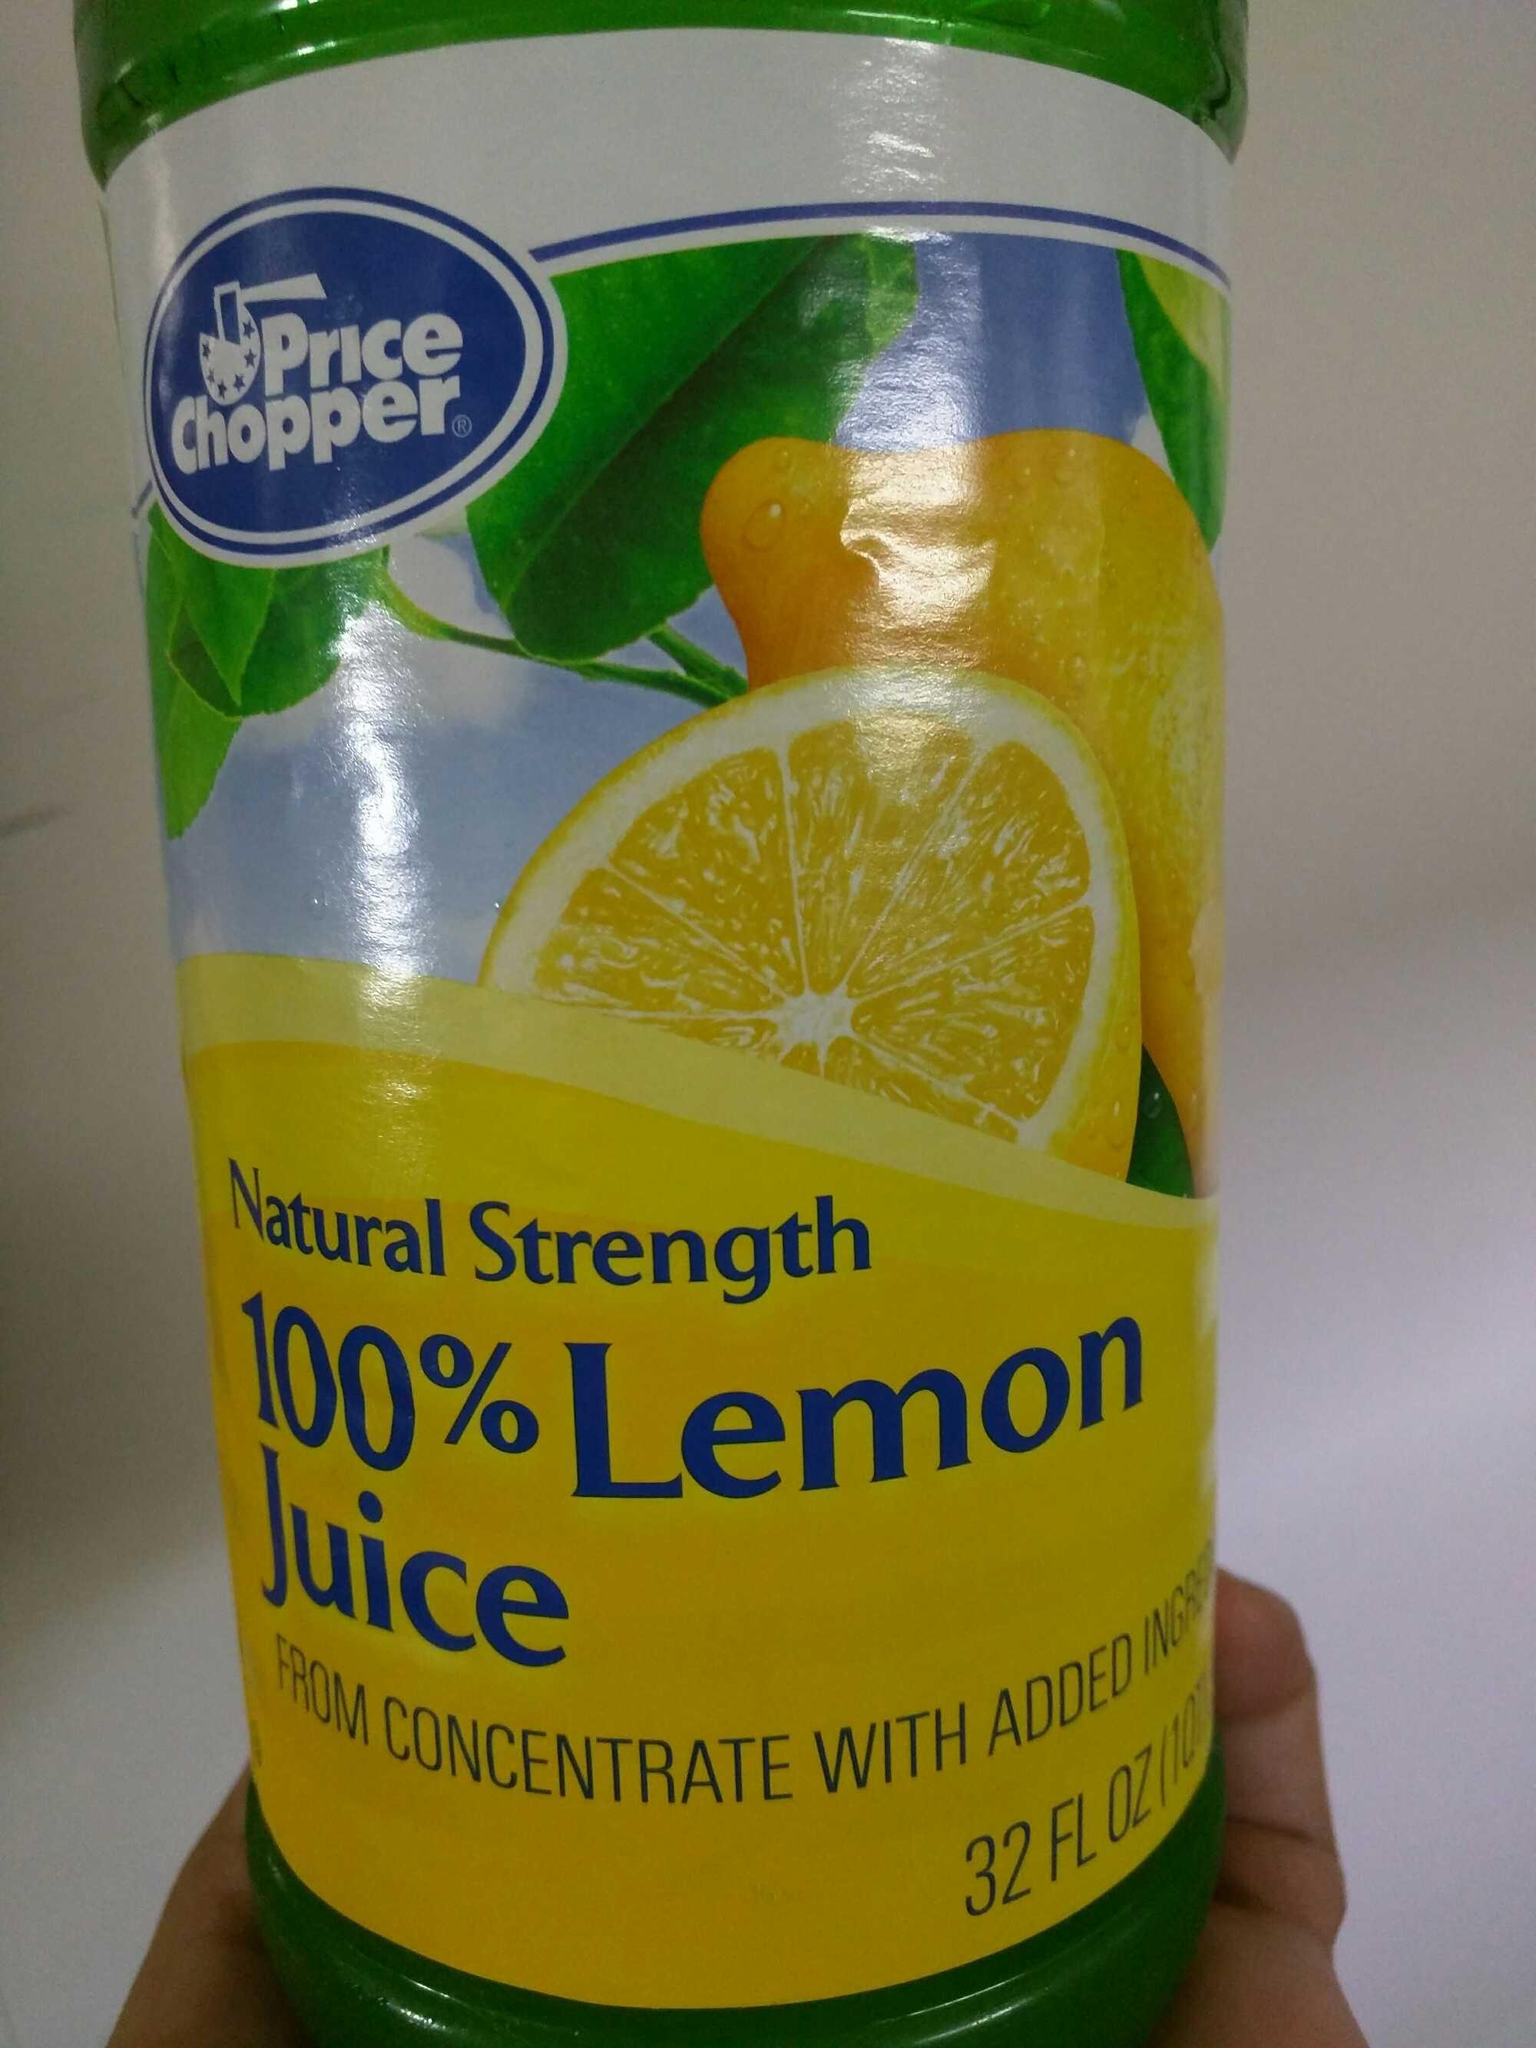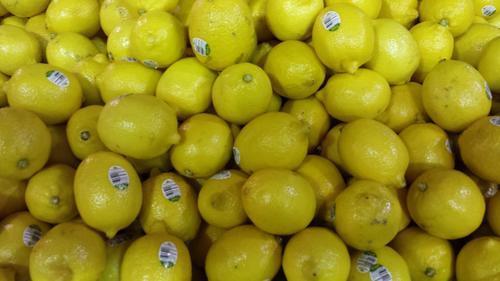The first image is the image on the left, the second image is the image on the right. Assess this claim about the two images: "The left image depicts a cut lemon half in front of a whole lemon and green leaves and include an upright product container, and the right image contains a mass of whole lemons only.". Correct or not? Answer yes or no. Yes. The first image is the image on the left, the second image is the image on the right. Considering the images on both sides, is "There is a real sliced lemon in the left image." valid? Answer yes or no. No. 